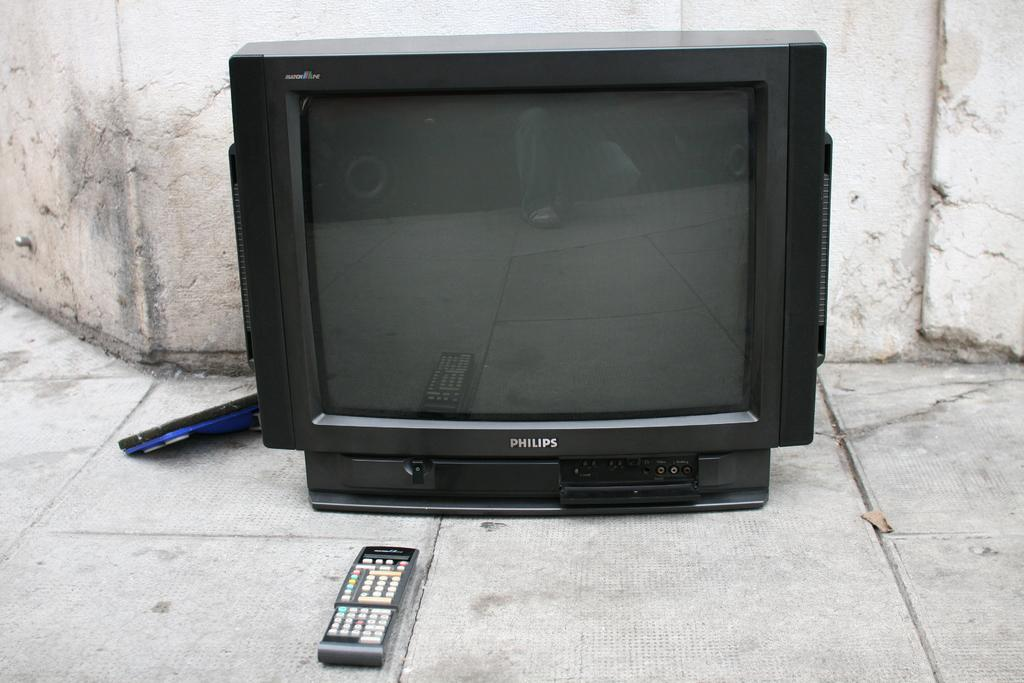<image>
Describe the image concisely. a Philips television that is on the concrete 